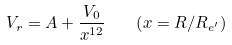Convert formula to latex. <formula><loc_0><loc_0><loc_500><loc_500>V _ { r } = A + \frac { V _ { 0 } } { x ^ { 1 2 } } \quad \left ( x = { R } / { R _ { e ^ { \prime } } } \right )</formula> 